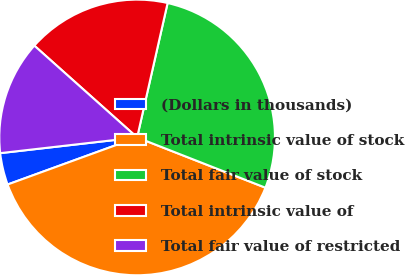Convert chart to OTSL. <chart><loc_0><loc_0><loc_500><loc_500><pie_chart><fcel>(Dollars in thousands)<fcel>Total intrinsic value of stock<fcel>Total fair value of stock<fcel>Total intrinsic value of<fcel>Total fair value of restricted<nl><fcel>3.73%<fcel>38.51%<fcel>27.39%<fcel>16.95%<fcel>13.42%<nl></chart> 